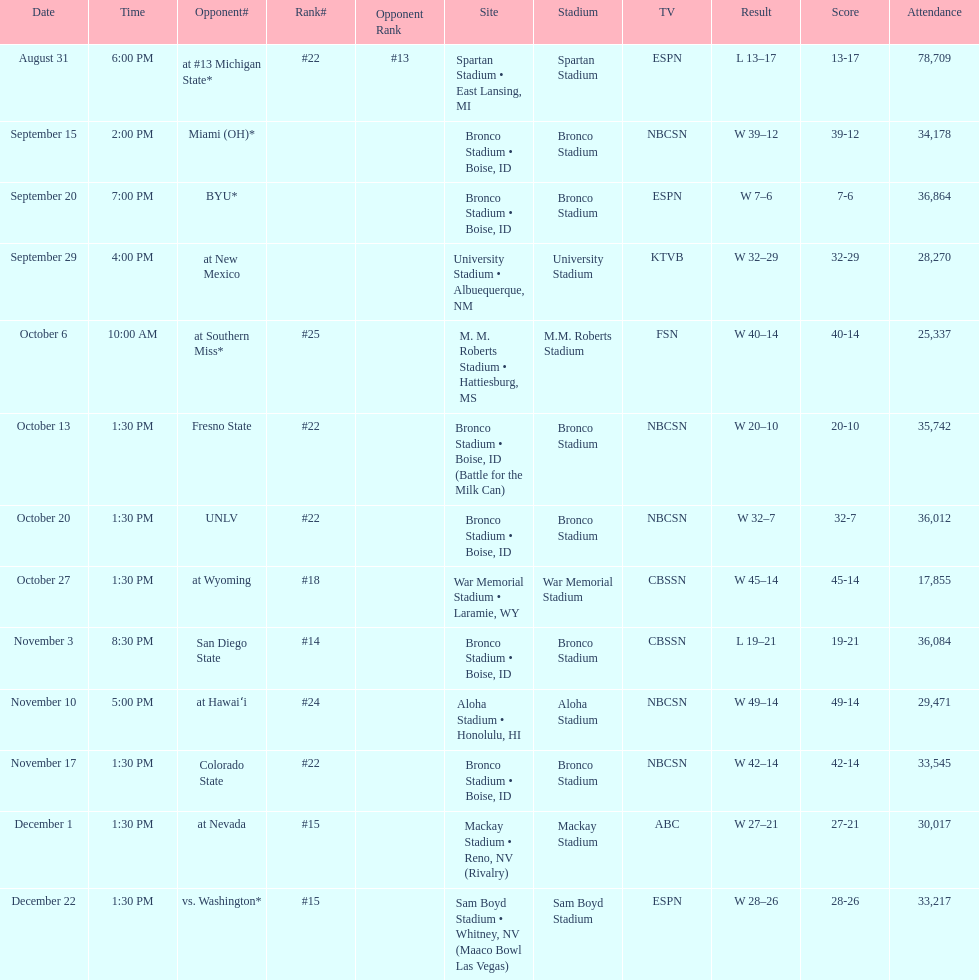In the latest winning games for boise state, how many points were scored in total? 146. Parse the table in full. {'header': ['Date', 'Time', 'Opponent#', 'Rank#', 'Opponent Rank', 'Site', 'Stadium', 'TV', 'Result', 'Score', 'Attendance'], 'rows': [['August 31', '6:00 PM', 'at\xa0#13\xa0Michigan State*', '#22', '#13', 'Spartan Stadium • East Lansing, MI', 'Spartan Stadium', 'ESPN', 'L\xa013–17', '13-17', '78,709'], ['September 15', '2:00 PM', 'Miami (OH)*', '', '', 'Bronco Stadium • Boise, ID', 'Bronco Stadium', 'NBCSN', 'W\xa039–12', '39-12', '34,178'], ['September 20', '7:00 PM', 'BYU*', '', '', 'Bronco Stadium • Boise, ID', 'Bronco Stadium', 'ESPN', 'W\xa07–6', '7-6', '36,864'], ['September 29', '4:00 PM', 'at\xa0New Mexico', '', '', 'University Stadium • Albuequerque, NM', 'University Stadium', 'KTVB', 'W\xa032–29', '32-29', '28,270'], ['October 6', '10:00 AM', 'at\xa0Southern Miss*', '#25', '', 'M. M. Roberts Stadium • Hattiesburg, MS', 'M.M. Roberts Stadium', 'FSN', 'W\xa040–14', '40-14', '25,337'], ['October 13', '1:30 PM', 'Fresno State', '#22', '', 'Bronco Stadium • Boise, ID (Battle for the Milk Can)', 'Bronco Stadium', 'NBCSN', 'W\xa020–10', '20-10', '35,742'], ['October 20', '1:30 PM', 'UNLV', '#22', '', 'Bronco Stadium • Boise, ID', 'Bronco Stadium', 'NBCSN', 'W\xa032–7', '32-7', '36,012'], ['October 27', '1:30 PM', 'at\xa0Wyoming', '#18', '', 'War Memorial Stadium • Laramie, WY', 'War Memorial Stadium', 'CBSSN', 'W\xa045–14', '45-14', '17,855'], ['November 3', '8:30 PM', 'San Diego State', '#14', '', 'Bronco Stadium • Boise, ID', 'Bronco Stadium', 'CBSSN', 'L\xa019–21', '19-21', '36,084'], ['November 10', '5:00 PM', 'at\xa0Hawaiʻi', '#24', '', 'Aloha Stadium • Honolulu, HI', 'Aloha Stadium', 'NBCSN', 'W\xa049–14', '49-14', '29,471'], ['November 17', '1:30 PM', 'Colorado State', '#22', '', 'Bronco Stadium • Boise, ID', 'Bronco Stadium', 'NBCSN', 'W\xa042–14', '42-14', '33,545'], ['December 1', '1:30 PM', 'at\xa0Nevada', '#15', '', 'Mackay Stadium • Reno, NV (Rivalry)', 'Mackay Stadium', 'ABC', 'W\xa027–21', '27-21', '30,017'], ['December 22', '1:30 PM', 'vs.\xa0Washington*', '#15', '', 'Sam Boyd Stadium • Whitney, NV (Maaco Bowl Las Vegas)', 'Sam Boyd Stadium', 'ESPN', 'W\xa028–26', '28-26', '33,217']]} 